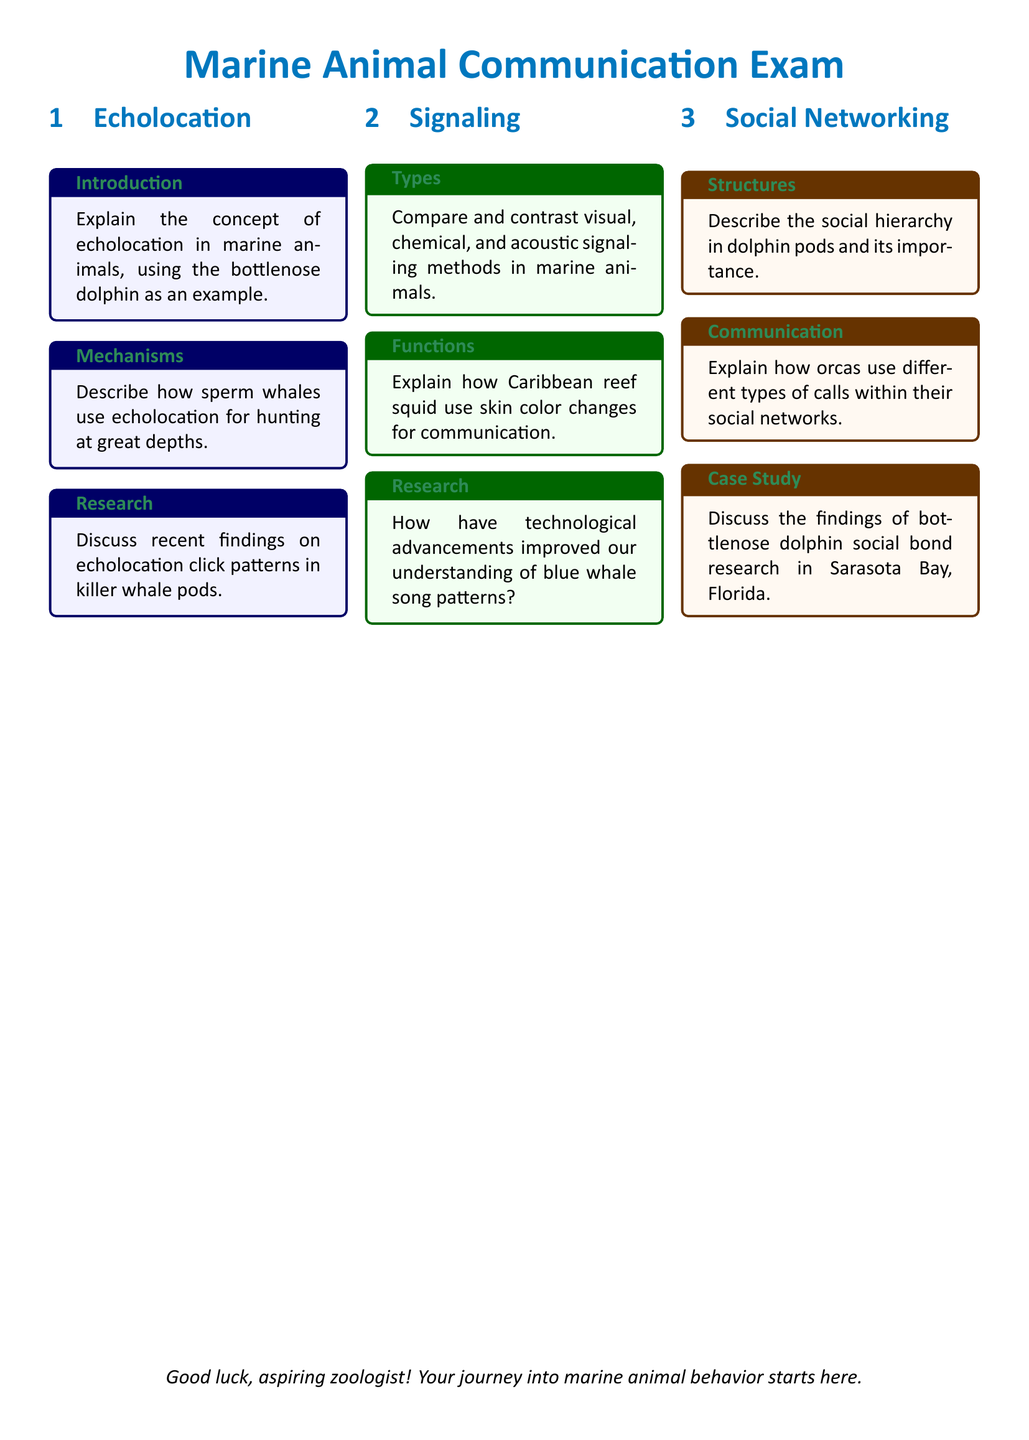What marine animal is used as an example for echolocation? The document mentions the bottlenose dolphin as an example of echolocation in marine animals.
Answer: bottlenose dolphin Which whale species uses echolocation for hunting at great depths? The document specifically identifies sperm whales as the species that uses echolocation for hunting at great depths.
Answer: sperm whales What type of signaling is compared with visual and chemical methods? The document asks to compare and contrast visual, chemical, and acoustic signaling methods in marine animals.
Answer: acoustic How do Caribbean reef squid communicate, according to the document? The document states that Caribbean reef squid use skin color changes for communication.
Answer: skin color changes What has improved our understanding of blue whale song patterns? The document notes that technological advancements have improved the understanding of blue whale song patterns.
Answer: technological advancements What is the focus of the social hierarchy description in dolphin pods? The document indicates that the description of the social hierarchy focuses on its importance.
Answer: importance What do orcas use within their social networks according to the document? The document mentions that orcas use different types of calls within their social networks.
Answer: different types of calls Where is the case study of bottlenose dolphin social bond research conducted? The document clearly states that the case study is conducted in Sarasota Bay, Florida.
Answer: Sarasota Bay, Florida 